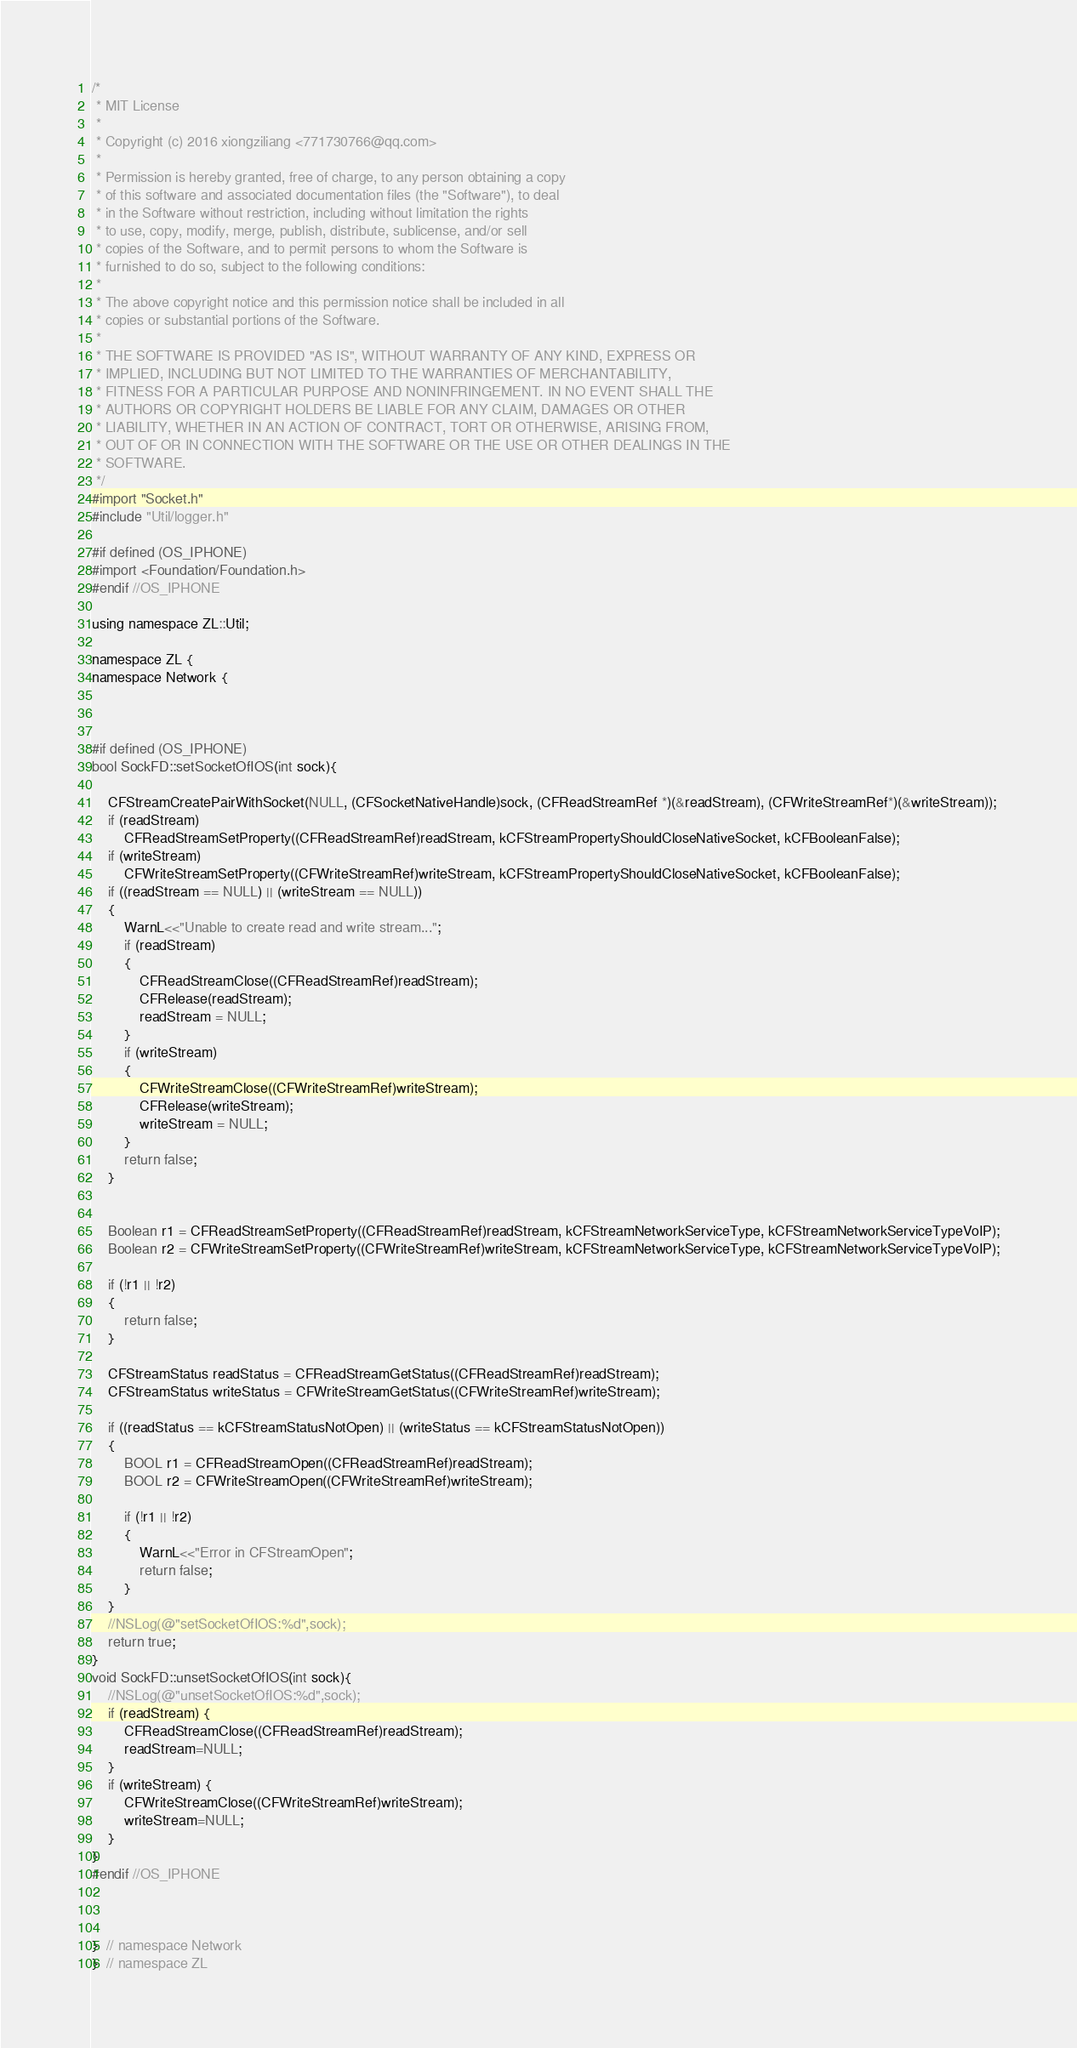<code> <loc_0><loc_0><loc_500><loc_500><_ObjectiveC_>/*
 * MIT License
 *
 * Copyright (c) 2016 xiongziliang <771730766@qq.com>
 *
 * Permission is hereby granted, free of charge, to any person obtaining a copy
 * of this software and associated documentation files (the "Software"), to deal
 * in the Software without restriction, including without limitation the rights
 * to use, copy, modify, merge, publish, distribute, sublicense, and/or sell
 * copies of the Software, and to permit persons to whom the Software is
 * furnished to do so, subject to the following conditions:
 *
 * The above copyright notice and this permission notice shall be included in all
 * copies or substantial portions of the Software.
 *
 * THE SOFTWARE IS PROVIDED "AS IS", WITHOUT WARRANTY OF ANY KIND, EXPRESS OR
 * IMPLIED, INCLUDING BUT NOT LIMITED TO THE WARRANTIES OF MERCHANTABILITY,
 * FITNESS FOR A PARTICULAR PURPOSE AND NONINFRINGEMENT. IN NO EVENT SHALL THE
 * AUTHORS OR COPYRIGHT HOLDERS BE LIABLE FOR ANY CLAIM, DAMAGES OR OTHER
 * LIABILITY, WHETHER IN AN ACTION OF CONTRACT, TORT OR OTHERWISE, ARISING FROM,
 * OUT OF OR IN CONNECTION WITH THE SOFTWARE OR THE USE OR OTHER DEALINGS IN THE
 * SOFTWARE.
 */
#import "Socket.h"
#include "Util/logger.h"

#if defined (OS_IPHONE)
#import <Foundation/Foundation.h>
#endif //OS_IPHONE

using namespace ZL::Util;

namespace ZL {
namespace Network {



#if defined (OS_IPHONE)
bool SockFD::setSocketOfIOS(int sock){
    
    CFStreamCreatePairWithSocket(NULL, (CFSocketNativeHandle)sock, (CFReadStreamRef *)(&readStream), (CFWriteStreamRef*)(&writeStream));
    if (readStream)
        CFReadStreamSetProperty((CFReadStreamRef)readStream, kCFStreamPropertyShouldCloseNativeSocket, kCFBooleanFalse);
    if (writeStream)
        CFWriteStreamSetProperty((CFWriteStreamRef)writeStream, kCFStreamPropertyShouldCloseNativeSocket, kCFBooleanFalse);
    if ((readStream == NULL) || (writeStream == NULL))
    {
        WarnL<<"Unable to create read and write stream...";
        if (readStream)
        {
            CFReadStreamClose((CFReadStreamRef)readStream);
            CFRelease(readStream);
            readStream = NULL;
        }
        if (writeStream)
        {
            CFWriteStreamClose((CFWriteStreamRef)writeStream);
            CFRelease(writeStream);
            writeStream = NULL;
        }
        return false;
    }
    
    
    Boolean r1 = CFReadStreamSetProperty((CFReadStreamRef)readStream, kCFStreamNetworkServiceType, kCFStreamNetworkServiceTypeVoIP);
    Boolean r2 = CFWriteStreamSetProperty((CFWriteStreamRef)writeStream, kCFStreamNetworkServiceType, kCFStreamNetworkServiceTypeVoIP);
    
    if (!r1 || !r2)
    {
        return false;
    }
    
    CFStreamStatus readStatus = CFReadStreamGetStatus((CFReadStreamRef)readStream);
    CFStreamStatus writeStatus = CFWriteStreamGetStatus((CFWriteStreamRef)writeStream);
    
    if ((readStatus == kCFStreamStatusNotOpen) || (writeStatus == kCFStreamStatusNotOpen))
    {
        BOOL r1 = CFReadStreamOpen((CFReadStreamRef)readStream);
        BOOL r2 = CFWriteStreamOpen((CFWriteStreamRef)writeStream);
        
        if (!r1 || !r2)
        {
            WarnL<<"Error in CFStreamOpen";
            return false;
        }
    }
    //NSLog(@"setSocketOfIOS:%d",sock);
    return true;
}
void SockFD::unsetSocketOfIOS(int sock){
    //NSLog(@"unsetSocketOfIOS:%d",sock);
    if (readStream) {
        CFReadStreamClose((CFReadStreamRef)readStream);
        readStream=NULL;
    }
    if (writeStream) {
        CFWriteStreamClose((CFWriteStreamRef)writeStream);
        writeStream=NULL;
    }
}
#endif //OS_IPHONE



}  // namespace Network
}  // namespace ZL
</code> 